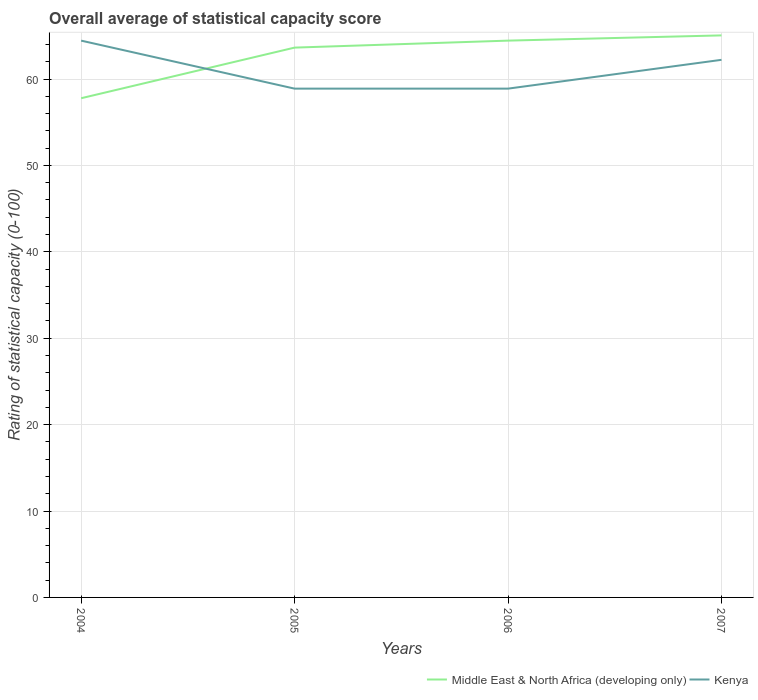Does the line corresponding to Middle East & North Africa (developing only) intersect with the line corresponding to Kenya?
Offer a terse response. Yes. Is the number of lines equal to the number of legend labels?
Make the answer very short. Yes. Across all years, what is the maximum rating of statistical capacity in Middle East & North Africa (developing only)?
Make the answer very short. 57.78. What is the total rating of statistical capacity in Kenya in the graph?
Your answer should be very brief. 0. What is the difference between the highest and the second highest rating of statistical capacity in Middle East & North Africa (developing only)?
Your response must be concise. 7.27. How many lines are there?
Your answer should be very brief. 2. How many years are there in the graph?
Provide a short and direct response. 4. Does the graph contain any zero values?
Your answer should be compact. No. How many legend labels are there?
Ensure brevity in your answer.  2. How are the legend labels stacked?
Offer a terse response. Horizontal. What is the title of the graph?
Your answer should be compact. Overall average of statistical capacity score. What is the label or title of the X-axis?
Give a very brief answer. Years. What is the label or title of the Y-axis?
Your answer should be very brief. Rating of statistical capacity (0-100). What is the Rating of statistical capacity (0-100) in Middle East & North Africa (developing only) in 2004?
Offer a very short reply. 57.78. What is the Rating of statistical capacity (0-100) of Kenya in 2004?
Give a very brief answer. 64.44. What is the Rating of statistical capacity (0-100) of Middle East & North Africa (developing only) in 2005?
Ensure brevity in your answer.  63.64. What is the Rating of statistical capacity (0-100) in Kenya in 2005?
Offer a very short reply. 58.89. What is the Rating of statistical capacity (0-100) in Middle East & North Africa (developing only) in 2006?
Offer a very short reply. 64.44. What is the Rating of statistical capacity (0-100) of Kenya in 2006?
Provide a short and direct response. 58.89. What is the Rating of statistical capacity (0-100) in Middle East & North Africa (developing only) in 2007?
Your answer should be compact. 65.05. What is the Rating of statistical capacity (0-100) of Kenya in 2007?
Provide a succinct answer. 62.22. Across all years, what is the maximum Rating of statistical capacity (0-100) in Middle East & North Africa (developing only)?
Make the answer very short. 65.05. Across all years, what is the maximum Rating of statistical capacity (0-100) in Kenya?
Your response must be concise. 64.44. Across all years, what is the minimum Rating of statistical capacity (0-100) in Middle East & North Africa (developing only)?
Offer a terse response. 57.78. Across all years, what is the minimum Rating of statistical capacity (0-100) of Kenya?
Give a very brief answer. 58.89. What is the total Rating of statistical capacity (0-100) of Middle East & North Africa (developing only) in the graph?
Offer a very short reply. 250.91. What is the total Rating of statistical capacity (0-100) of Kenya in the graph?
Your answer should be compact. 244.44. What is the difference between the Rating of statistical capacity (0-100) in Middle East & North Africa (developing only) in 2004 and that in 2005?
Provide a short and direct response. -5.86. What is the difference between the Rating of statistical capacity (0-100) in Kenya in 2004 and that in 2005?
Ensure brevity in your answer.  5.56. What is the difference between the Rating of statistical capacity (0-100) in Middle East & North Africa (developing only) in 2004 and that in 2006?
Offer a terse response. -6.67. What is the difference between the Rating of statistical capacity (0-100) in Kenya in 2004 and that in 2006?
Offer a terse response. 5.56. What is the difference between the Rating of statistical capacity (0-100) of Middle East & North Africa (developing only) in 2004 and that in 2007?
Your answer should be very brief. -7.27. What is the difference between the Rating of statistical capacity (0-100) of Kenya in 2004 and that in 2007?
Your answer should be very brief. 2.22. What is the difference between the Rating of statistical capacity (0-100) of Middle East & North Africa (developing only) in 2005 and that in 2006?
Keep it short and to the point. -0.81. What is the difference between the Rating of statistical capacity (0-100) of Kenya in 2005 and that in 2006?
Ensure brevity in your answer.  0. What is the difference between the Rating of statistical capacity (0-100) of Middle East & North Africa (developing only) in 2005 and that in 2007?
Make the answer very short. -1.41. What is the difference between the Rating of statistical capacity (0-100) in Kenya in 2005 and that in 2007?
Ensure brevity in your answer.  -3.33. What is the difference between the Rating of statistical capacity (0-100) of Middle East & North Africa (developing only) in 2006 and that in 2007?
Offer a very short reply. -0.61. What is the difference between the Rating of statistical capacity (0-100) of Middle East & North Africa (developing only) in 2004 and the Rating of statistical capacity (0-100) of Kenya in 2005?
Provide a succinct answer. -1.11. What is the difference between the Rating of statistical capacity (0-100) in Middle East & North Africa (developing only) in 2004 and the Rating of statistical capacity (0-100) in Kenya in 2006?
Ensure brevity in your answer.  -1.11. What is the difference between the Rating of statistical capacity (0-100) of Middle East & North Africa (developing only) in 2004 and the Rating of statistical capacity (0-100) of Kenya in 2007?
Make the answer very short. -4.44. What is the difference between the Rating of statistical capacity (0-100) of Middle East & North Africa (developing only) in 2005 and the Rating of statistical capacity (0-100) of Kenya in 2006?
Give a very brief answer. 4.75. What is the difference between the Rating of statistical capacity (0-100) in Middle East & North Africa (developing only) in 2005 and the Rating of statistical capacity (0-100) in Kenya in 2007?
Your response must be concise. 1.41. What is the difference between the Rating of statistical capacity (0-100) of Middle East & North Africa (developing only) in 2006 and the Rating of statistical capacity (0-100) of Kenya in 2007?
Offer a terse response. 2.22. What is the average Rating of statistical capacity (0-100) in Middle East & North Africa (developing only) per year?
Keep it short and to the point. 62.73. What is the average Rating of statistical capacity (0-100) in Kenya per year?
Offer a terse response. 61.11. In the year 2004, what is the difference between the Rating of statistical capacity (0-100) in Middle East & North Africa (developing only) and Rating of statistical capacity (0-100) in Kenya?
Provide a succinct answer. -6.67. In the year 2005, what is the difference between the Rating of statistical capacity (0-100) in Middle East & North Africa (developing only) and Rating of statistical capacity (0-100) in Kenya?
Give a very brief answer. 4.75. In the year 2006, what is the difference between the Rating of statistical capacity (0-100) of Middle East & North Africa (developing only) and Rating of statistical capacity (0-100) of Kenya?
Ensure brevity in your answer.  5.56. In the year 2007, what is the difference between the Rating of statistical capacity (0-100) of Middle East & North Africa (developing only) and Rating of statistical capacity (0-100) of Kenya?
Make the answer very short. 2.83. What is the ratio of the Rating of statistical capacity (0-100) in Middle East & North Africa (developing only) in 2004 to that in 2005?
Offer a terse response. 0.91. What is the ratio of the Rating of statistical capacity (0-100) in Kenya in 2004 to that in 2005?
Give a very brief answer. 1.09. What is the ratio of the Rating of statistical capacity (0-100) of Middle East & North Africa (developing only) in 2004 to that in 2006?
Offer a very short reply. 0.9. What is the ratio of the Rating of statistical capacity (0-100) in Kenya in 2004 to that in 2006?
Give a very brief answer. 1.09. What is the ratio of the Rating of statistical capacity (0-100) in Middle East & North Africa (developing only) in 2004 to that in 2007?
Your answer should be compact. 0.89. What is the ratio of the Rating of statistical capacity (0-100) of Kenya in 2004 to that in 2007?
Ensure brevity in your answer.  1.04. What is the ratio of the Rating of statistical capacity (0-100) in Middle East & North Africa (developing only) in 2005 to that in 2006?
Make the answer very short. 0.99. What is the ratio of the Rating of statistical capacity (0-100) in Middle East & North Africa (developing only) in 2005 to that in 2007?
Make the answer very short. 0.98. What is the ratio of the Rating of statistical capacity (0-100) of Kenya in 2005 to that in 2007?
Keep it short and to the point. 0.95. What is the ratio of the Rating of statistical capacity (0-100) of Middle East & North Africa (developing only) in 2006 to that in 2007?
Your response must be concise. 0.99. What is the ratio of the Rating of statistical capacity (0-100) in Kenya in 2006 to that in 2007?
Offer a very short reply. 0.95. What is the difference between the highest and the second highest Rating of statistical capacity (0-100) in Middle East & North Africa (developing only)?
Your response must be concise. 0.61. What is the difference between the highest and the second highest Rating of statistical capacity (0-100) of Kenya?
Make the answer very short. 2.22. What is the difference between the highest and the lowest Rating of statistical capacity (0-100) of Middle East & North Africa (developing only)?
Your answer should be compact. 7.27. What is the difference between the highest and the lowest Rating of statistical capacity (0-100) in Kenya?
Offer a terse response. 5.56. 